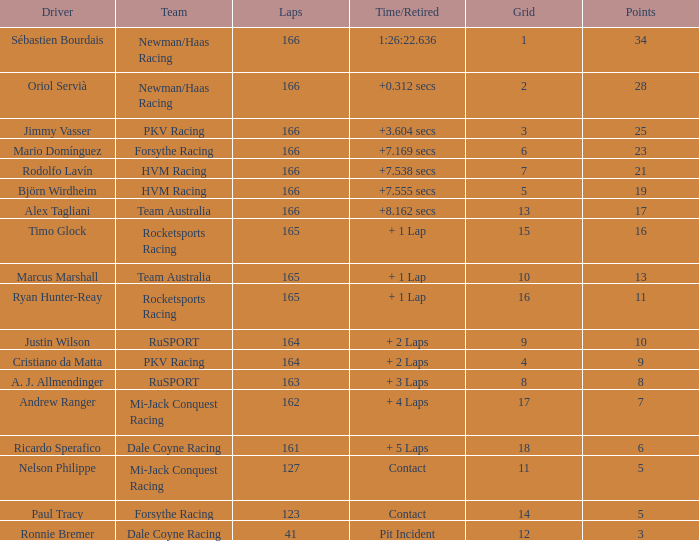What is the biggest points when the grid is less than 13 and the time/retired is +7.538 secs? 21.0. Could you parse the entire table as a dict? {'header': ['Driver', 'Team', 'Laps', 'Time/Retired', 'Grid', 'Points'], 'rows': [['Sébastien Bourdais', 'Newman/Haas Racing', '166', '1:26:22.636', '1', '34'], ['Oriol Servià', 'Newman/Haas Racing', '166', '+0.312 secs', '2', '28'], ['Jimmy Vasser', 'PKV Racing', '166', '+3.604 secs', '3', '25'], ['Mario Domínguez', 'Forsythe Racing', '166', '+7.169 secs', '6', '23'], ['Rodolfo Lavín', 'HVM Racing', '166', '+7.538 secs', '7', '21'], ['Björn Wirdheim', 'HVM Racing', '166', '+7.555 secs', '5', '19'], ['Alex Tagliani', 'Team Australia', '166', '+8.162 secs', '13', '17'], ['Timo Glock', 'Rocketsports Racing', '165', '+ 1 Lap', '15', '16'], ['Marcus Marshall', 'Team Australia', '165', '+ 1 Lap', '10', '13'], ['Ryan Hunter-Reay', 'Rocketsports Racing', '165', '+ 1 Lap', '16', '11'], ['Justin Wilson', 'RuSPORT', '164', '+ 2 Laps', '9', '10'], ['Cristiano da Matta', 'PKV Racing', '164', '+ 2 Laps', '4', '9'], ['A. J. Allmendinger', 'RuSPORT', '163', '+ 3 Laps', '8', '8'], ['Andrew Ranger', 'Mi-Jack Conquest Racing', '162', '+ 4 Laps', '17', '7'], ['Ricardo Sperafico', 'Dale Coyne Racing', '161', '+ 5 Laps', '18', '6'], ['Nelson Philippe', 'Mi-Jack Conquest Racing', '127', 'Contact', '11', '5'], ['Paul Tracy', 'Forsythe Racing', '123', 'Contact', '14', '5'], ['Ronnie Bremer', 'Dale Coyne Racing', '41', 'Pit Incident', '12', '3']]} 